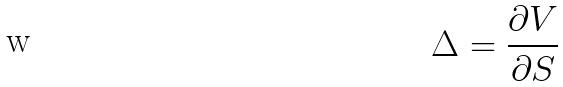<formula> <loc_0><loc_0><loc_500><loc_500>\Delta = \frac { \partial V } { \partial S }</formula> 